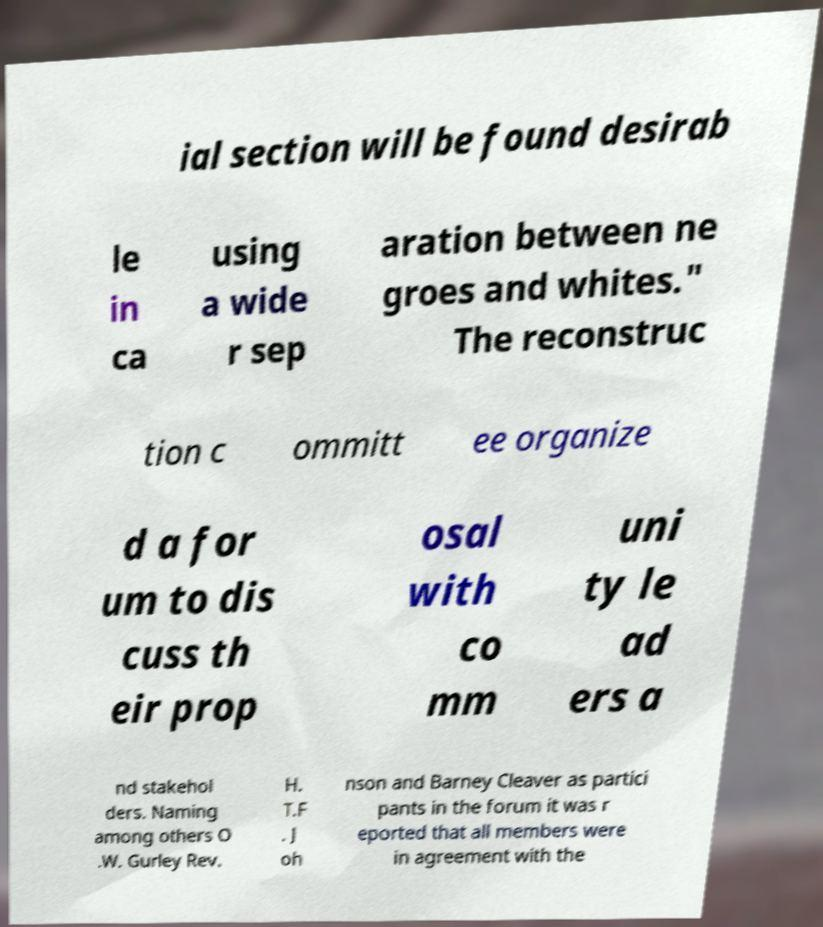What messages or text are displayed in this image? I need them in a readable, typed format. ial section will be found desirab le in ca using a wide r sep aration between ne groes and whites." The reconstruc tion c ommitt ee organize d a for um to dis cuss th eir prop osal with co mm uni ty le ad ers a nd stakehol ders. Naming among others O .W. Gurley Rev. H. T.F . J oh nson and Barney Cleaver as partici pants in the forum it was r eported that all members were in agreement with the 